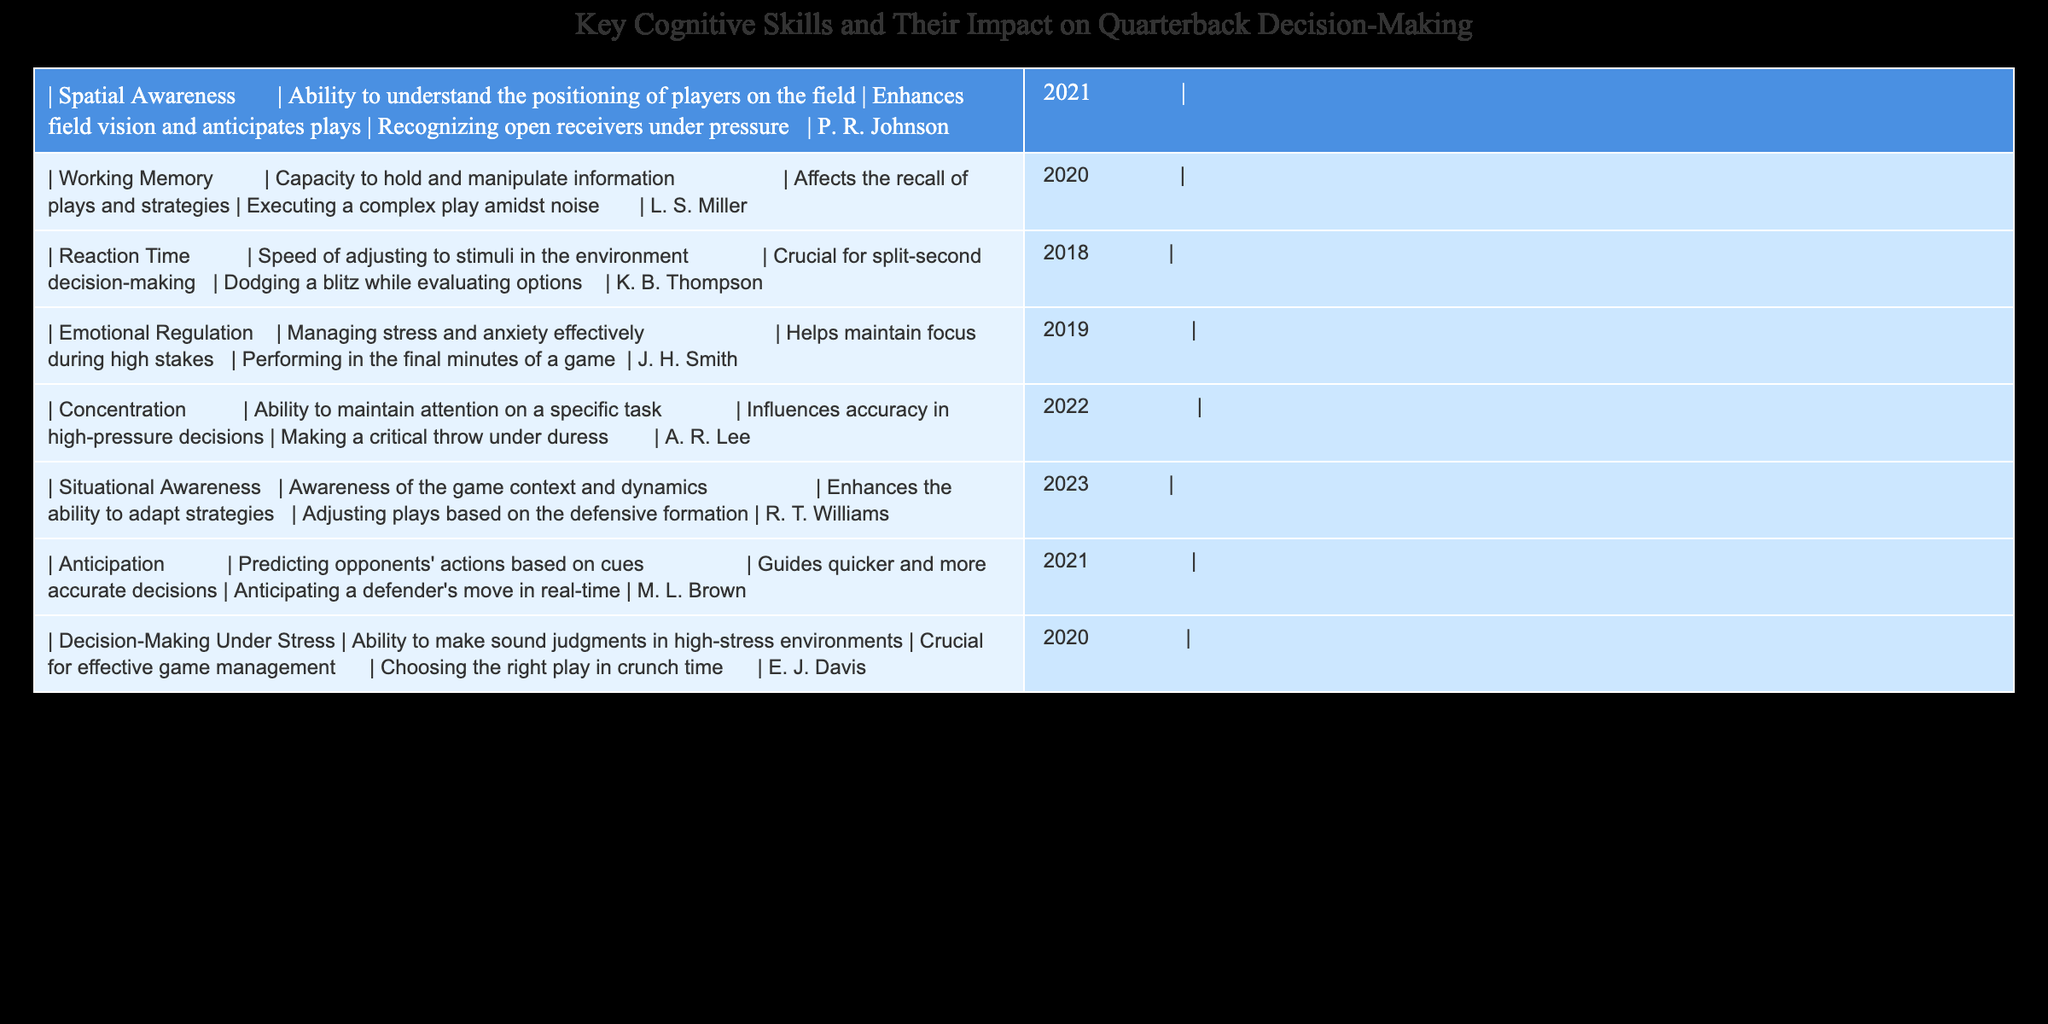What is the main impact of Spatial Awareness on quarterback decision-making? Based on the table, Spatial Awareness is described as enhancing field vision and anticipating plays, which indicates its importance in recognizing open receivers under pressure.
Answer: Enhances field vision and anticipates plays Which cognitive skill directly influences the execution of complex plays amidst noise? The table indicates that Working Memory is the cognitive skill that affects the recall of plays and strategies, which is crucial for executing complex plays in noisy environments.
Answer: Working Memory Is Emotional Regulation essential for performance in the final minutes of a game? According to the table, Emotional Regulation helps maintain focus during high-stakes situations, particularly in the final minutes of a game, suggesting that it is indeed essential.
Answer: Yes How do Reaction Time and Anticipation compare in their significance to quarterback decision-making? Reaction Time is crucial for split-second decision-making, while Anticipation guides quicker and more accurate decisions. Both are critical, but Reaction Time emphasizes speed, and Anticipation involves predicting actions. Therefore, they serve different but equally important roles in decision-making.
Answer: They have different but equally important roles Which cognitive skill has the most recent research cited in the table? The table lists Situational Awareness, with research published in 2023 by R. T. Williams, indicating it is the most recently cited cognitive skill in the context of quarterback decision-making.
Answer: Situational Awareness What is the overall focus of the cognitive skills listed in relation to quarterbacks? All skills listed in the table are focused on enhancing decision-making capabilities during high-pressure situations in games, impacting performance significantly.
Answer: Enhancing decision-making in high-pressure situations What might be the implication of having poor Concentration for a quarterback? A lack of Concentration can lead to decreased accuracy in high-pressure decisions, suggesting it could result in costly mistakes during crucial game moments.
Answer: Costly mistakes in crucial moments Is there a significant distinction in the roles of Decision-Making Under Stress and Emotional Regulation? While both are related to management during stress, Decision-Making Under Stress focuses on making sound judgments in high-stress environments, whereas Emotional Regulation specifically addresses managing stress and anxiety effectively. This indicates that they contribute to different aspects of performance.
Answer: Yes, they contribute to different aspects of performance 